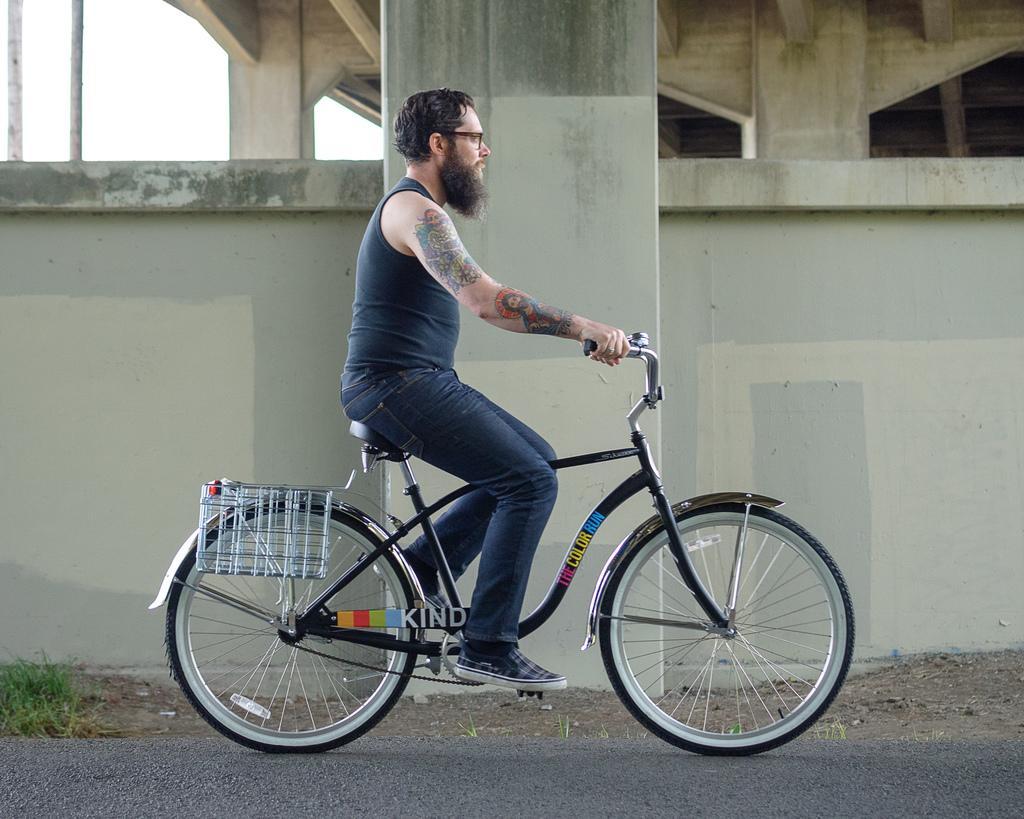How would you summarize this image in a sentence or two? A man is riding a bicycle. Man wears blue vest and blue denim pant with casual shoe. He has a long beard and short hair,wears spectacles. There is a wall and a pillar to left of him. From a distance, it is looking as if he is passing through a bridge. 